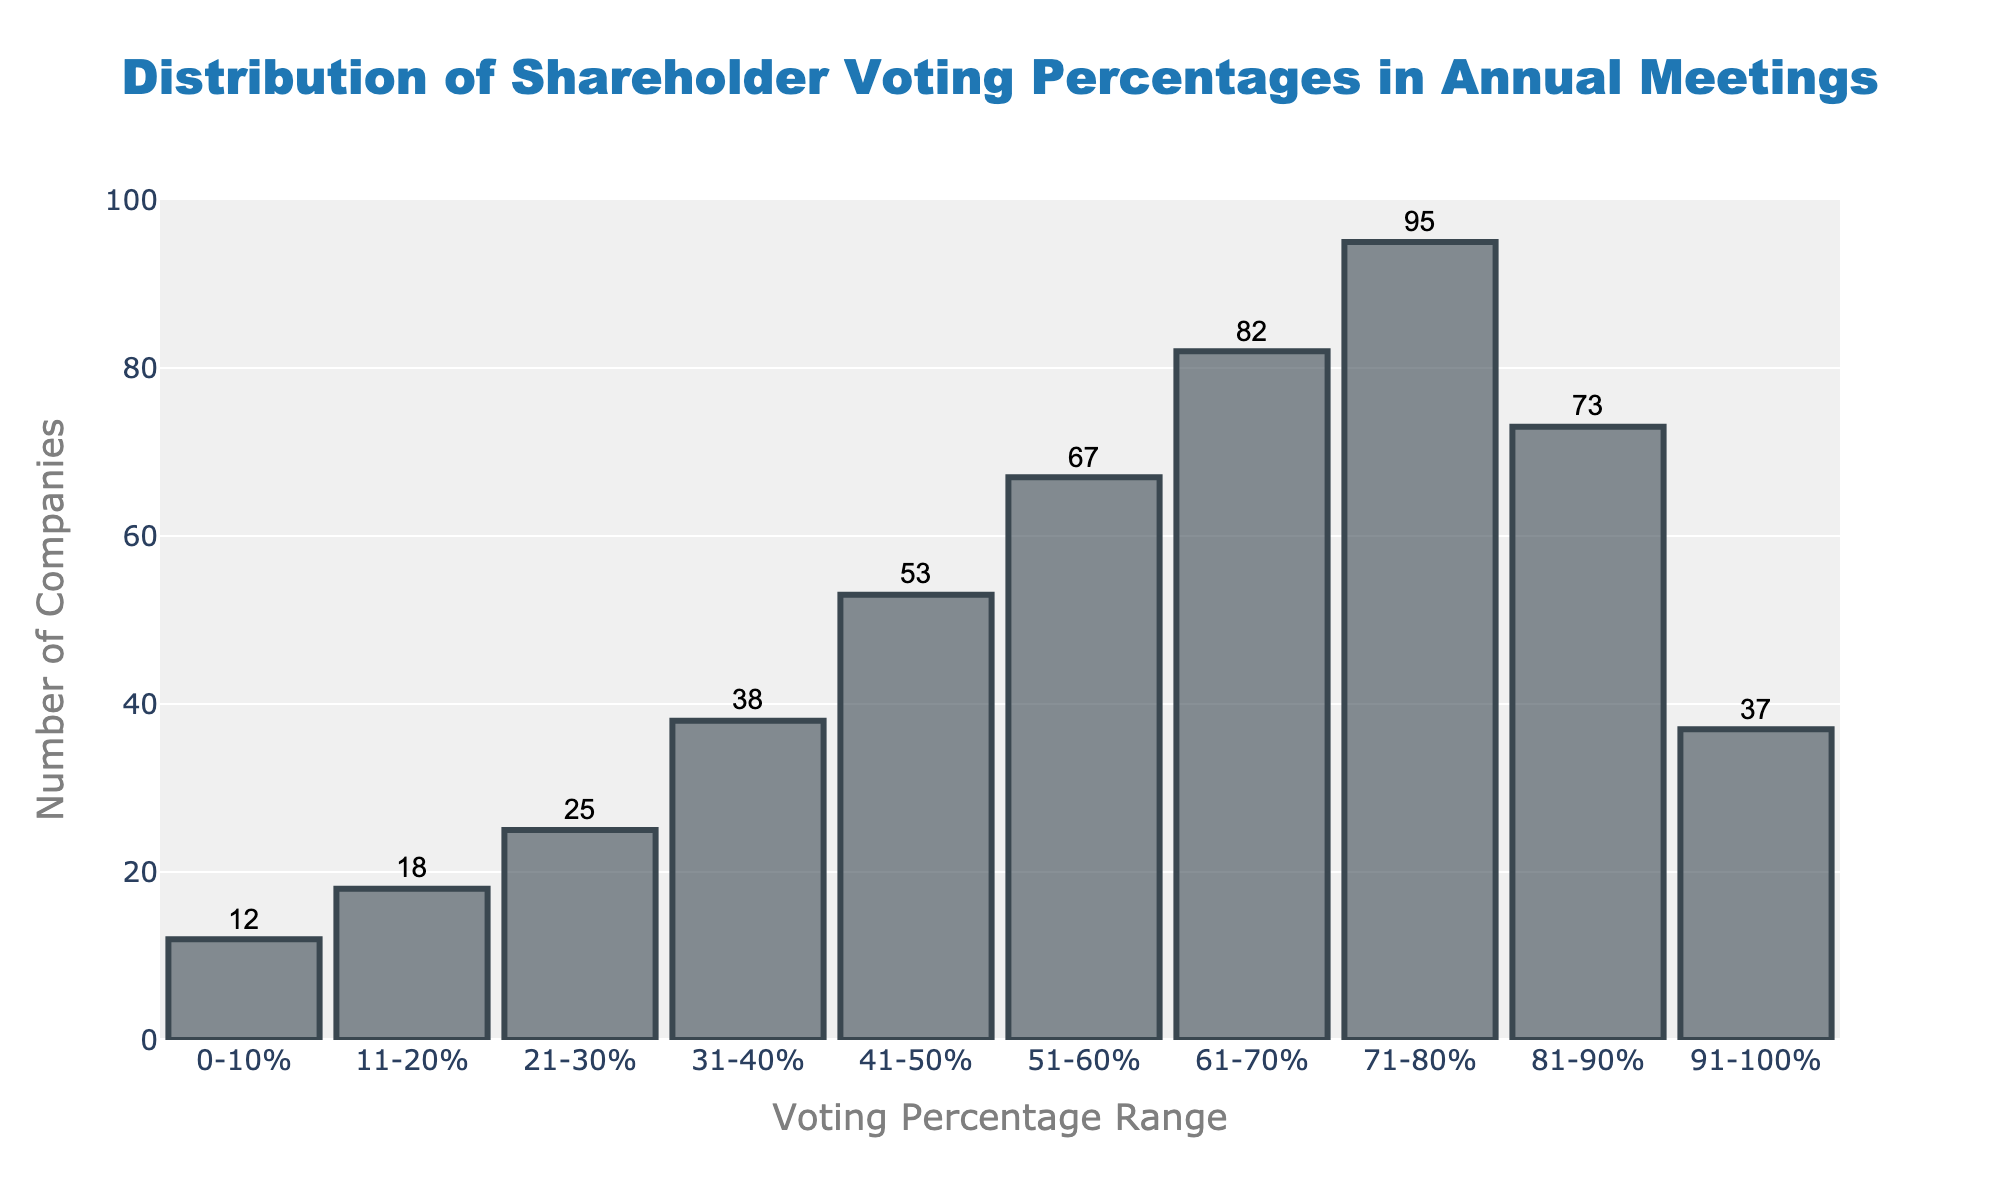What is the title of the histogram? The title of the histogram is located at the center top of the figure. It reads 'Distribution of Shareholder Voting Percentages in Annual Meetings'.
Answer: Distribution of Shareholder Voting Percentages in Annual Meetings What does the x-axis represent in the histogram? The x-axis represents the range of voting percentages, showing different intervals such as 0-10%, 11-20%, etc.
Answer: Voting Percentage Range How many companies fall within the 41-50% voting percentage range? To find this, locate the bar labeled 41-50% on the x-axis. The height of the bar, along with the text annotation on top, indicates 53 companies.
Answer: 53 Which voting percentage range has the highest number of companies? Examine the heights of the bars to identify the tallest one. The bar for the 71-80% range is the tallest, with a count of 95 companies.
Answer: 71-80% How does the number of companies in the 91-100% range compare to the 51-60% range? Compare the heights of the bars for 91-100% and 51-60%. The 91-100% range has 37 companies, while the 51-60% range has 67 companies, so the 91-100% range has fewer companies.
Answer: Fewer What is the total number of companies represented in the histogram? Sum the company counts for all the voting percentage ranges: 12 + 18 + 25 + 38 + 53 + 67 + 82 + 95 + 73 + 37.
Answer: 500 What is the average number of companies per voting percentage range? The histogram shows 10 different voting percentage ranges. The total number of companies is 500. Divide the total by the number of ranges: 500 / 10.
Answer: 50 Are there more companies in the 21-30% range or the 81-90% range? Compare the bar heights and annotations. The 21-30% range has 25 companies, while the 81-90% range has 73 companies, meaning there are more companies in the 81-90% range.
Answer: 81-90% Which voting percentage ranges have fewer than 20 companies? Check the bars for company counts. The 0-10% range with 12 companies and the 11-20% range with 18 companies both have fewer than 20 companies.
Answer: 0-10% and 11-20% By how much does the number of companies in the 61-70% range exceed those in the 0-10% range? Subtract the number of companies in the 0-10% range (12) from the number in the 61-70% range (82): 82 - 12.
Answer: 70 